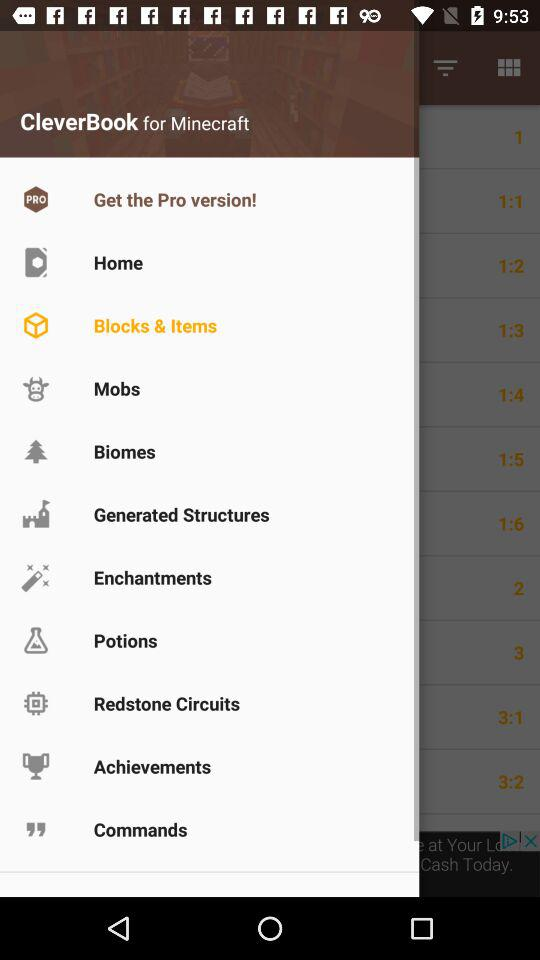Which item has been selected? The item that has been selected is "Blocks & Items". 